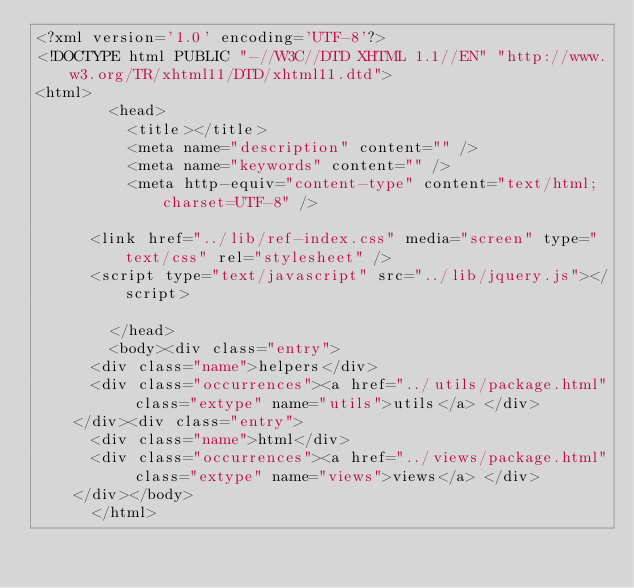Convert code to text. <code><loc_0><loc_0><loc_500><loc_500><_HTML_><?xml version='1.0' encoding='UTF-8'?>
<!DOCTYPE html PUBLIC "-//W3C//DTD XHTML 1.1//EN" "http://www.w3.org/TR/xhtml11/DTD/xhtml11.dtd">
<html>
        <head>
          <title></title>
          <meta name="description" content="" />
          <meta name="keywords" content="" />
          <meta http-equiv="content-type" content="text/html; charset=UTF-8" />
          
      <link href="../lib/ref-index.css" media="screen" type="text/css" rel="stylesheet" />
      <script type="text/javascript" src="../lib/jquery.js"></script>
    
        </head>
        <body><div class="entry">
      <div class="name">helpers</div>
      <div class="occurrences"><a href="../utils/package.html" class="extype" name="utils">utils</a> </div>
    </div><div class="entry">
      <div class="name">html</div>
      <div class="occurrences"><a href="../views/package.html" class="extype" name="views">views</a> </div>
    </div></body>
      </html></code> 